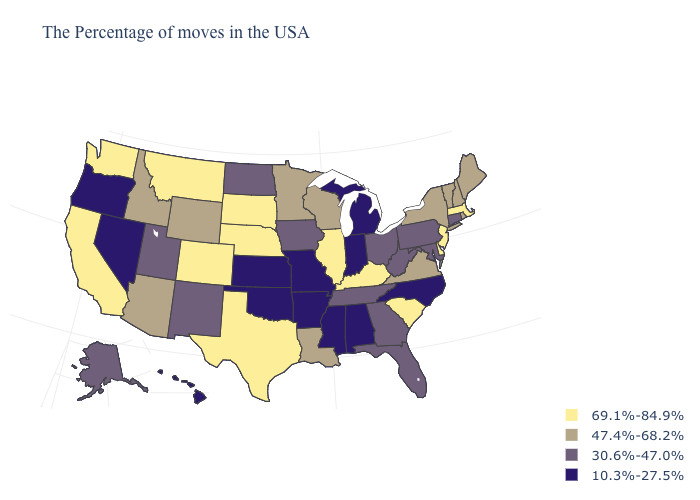What is the highest value in the MidWest ?
Short answer required. 69.1%-84.9%. What is the value of Mississippi?
Short answer required. 10.3%-27.5%. Does the map have missing data?
Give a very brief answer. No. What is the lowest value in the South?
Keep it brief. 10.3%-27.5%. How many symbols are there in the legend?
Quick response, please. 4. What is the highest value in the West ?
Answer briefly. 69.1%-84.9%. Name the states that have a value in the range 47.4%-68.2%?
Keep it brief. Maine, Rhode Island, New Hampshire, Vermont, New York, Virginia, Wisconsin, Louisiana, Minnesota, Wyoming, Arizona, Idaho. Name the states that have a value in the range 30.6%-47.0%?
Quick response, please. Connecticut, Maryland, Pennsylvania, West Virginia, Ohio, Florida, Georgia, Tennessee, Iowa, North Dakota, New Mexico, Utah, Alaska. What is the lowest value in the USA?
Give a very brief answer. 10.3%-27.5%. Does Louisiana have the highest value in the USA?
Write a very short answer. No. Name the states that have a value in the range 47.4%-68.2%?
Keep it brief. Maine, Rhode Island, New Hampshire, Vermont, New York, Virginia, Wisconsin, Louisiana, Minnesota, Wyoming, Arizona, Idaho. Which states have the highest value in the USA?
Concise answer only. Massachusetts, New Jersey, Delaware, South Carolina, Kentucky, Illinois, Nebraska, Texas, South Dakota, Colorado, Montana, California, Washington. Does the map have missing data?
Be succinct. No. Name the states that have a value in the range 30.6%-47.0%?
Short answer required. Connecticut, Maryland, Pennsylvania, West Virginia, Ohio, Florida, Georgia, Tennessee, Iowa, North Dakota, New Mexico, Utah, Alaska. What is the lowest value in states that border Rhode Island?
Short answer required. 30.6%-47.0%. 